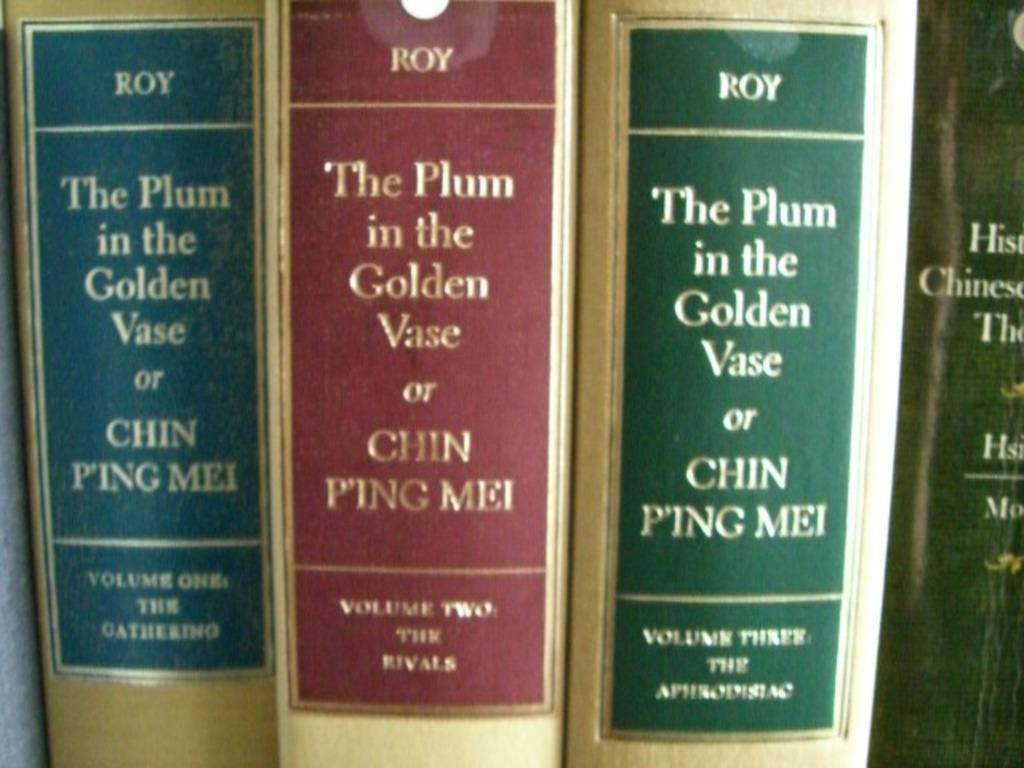<image>
Relay a brief, clear account of the picture shown. Several multi-colored book spines that read The Plum in the Golden Vase or CHIN PING MEI. 